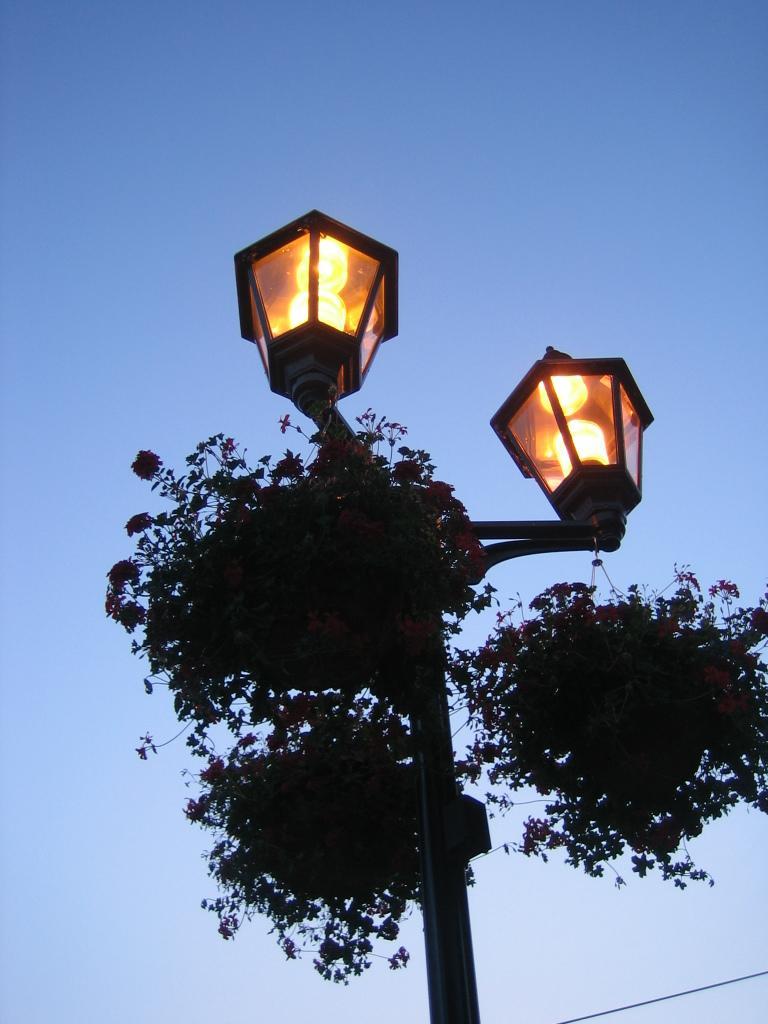How would you summarize this image in a sentence or two? In the image there is a pole with lamps and pots with plants and flowers. In the background there is a sky. 